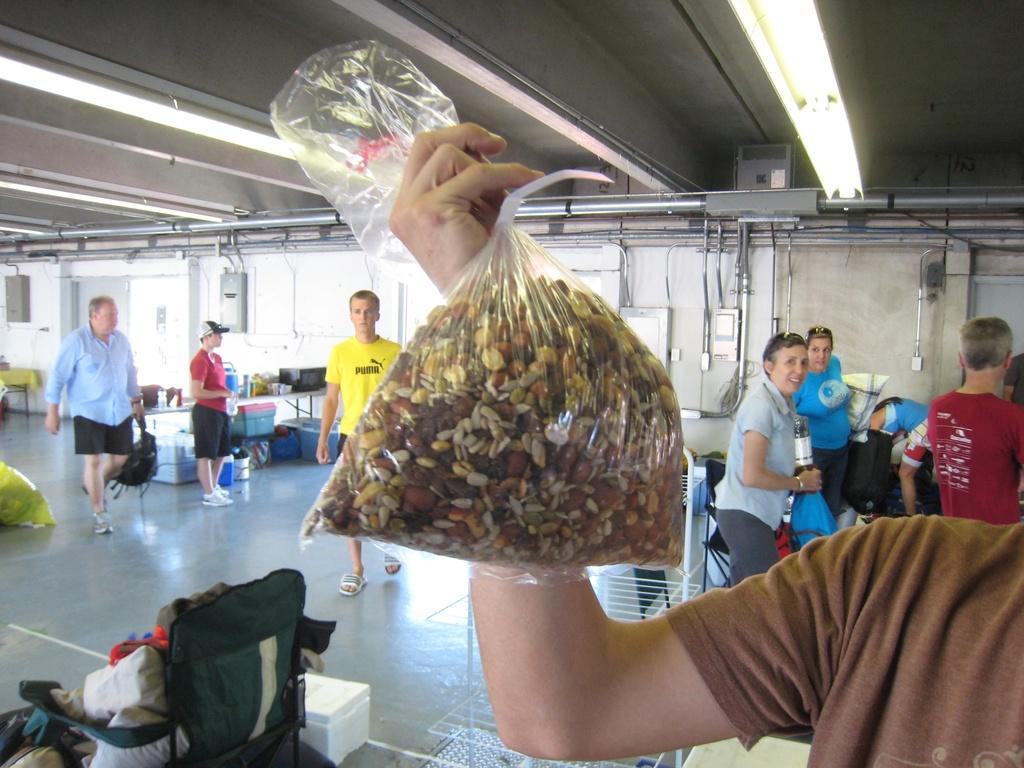In one or two sentences, can you explain what this image depicts? On the right we can see a person is holding a packet with nuts and other items in it. In the background there are few persons standing and walking on the floor,bags,rack stand,boxes,pipes,poles,lights on the roof top,electronic devices and other objects. 